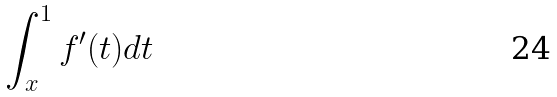Convert formula to latex. <formula><loc_0><loc_0><loc_500><loc_500>\int _ { x } ^ { 1 } f ^ { \prime } ( t ) d t</formula> 